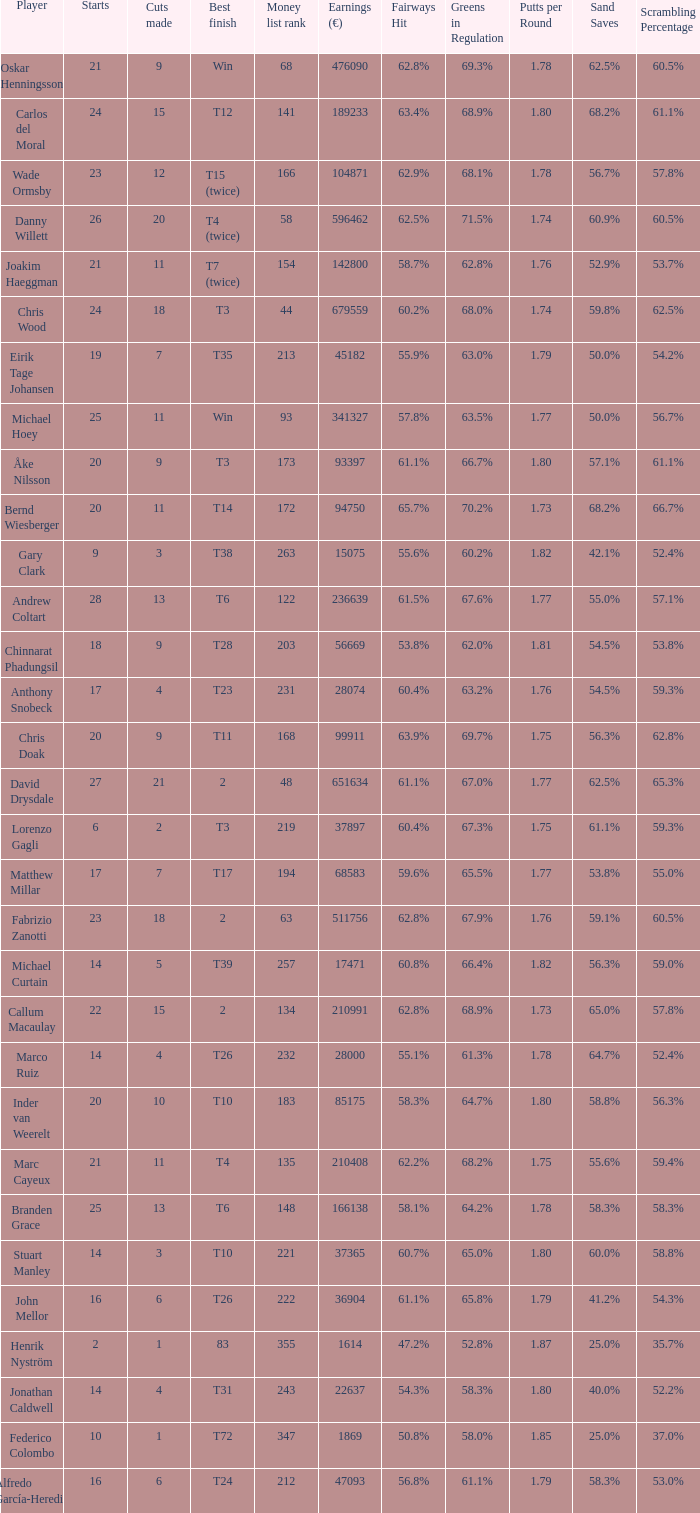How many earnings values are associated with players who had a best finish of T38? 1.0. I'm looking to parse the entire table for insights. Could you assist me with that? {'header': ['Player', 'Starts', 'Cuts made', 'Best finish', 'Money list rank', 'Earnings (€)', 'Fairways Hit', 'Greens in Regulation', 'Putts per Round', 'Sand Saves', 'Scrambling Percentage'], 'rows': [['Oskar Henningsson', '21', '9', 'Win', '68', '476090', '62.8%', '69.3%', '1.78', '62.5%', '60.5%'], ['Carlos del Moral', '24', '15', 'T12', '141', '189233', '63.4%', '68.9%', '1.80', '68.2%', '61.1%'], ['Wade Ormsby', '23', '12', 'T15 (twice)', '166', '104871', '62.9%', '68.1%', '1.78', '56.7%', '57.8%'], ['Danny Willett', '26', '20', 'T4 (twice)', '58', '596462', '62.5%', '71.5%', '1.74', '60.9%', '60.5%'], ['Joakim Haeggman', '21', '11', 'T7 (twice)', '154', '142800', '58.7%', '62.8%', '1.76', '52.9%', '53.7%'], ['Chris Wood', '24', '18', 'T3', '44', '679559', '60.2%', '68.0%', '1.74', '59.8%', '62.5%'], ['Eirik Tage Johansen', '19', '7', 'T35', '213', '45182', '55.9%', '63.0%', '1.79', '50.0%', '54.2%'], ['Michael Hoey', '25', '11', 'Win', '93', '341327', '57.8%', '63.5%', '1.77', '50.0%', '56.7%'], ['Åke Nilsson', '20', '9', 'T3', '173', '93397', '61.1%', '66.7%', '1.80', '57.1%', '61.1%'], ['Bernd Wiesberger', '20', '11', 'T14', '172', '94750', '65.7%', '70.2%', '1.73', '68.2%', '66.7%'], ['Gary Clark', '9', '3', 'T38', '263', '15075', '55.6%', '60.2%', '1.82', '42.1%', '52.4%'], ['Andrew Coltart', '28', '13', 'T6', '122', '236639', '61.5%', '67.6%', '1.77', '55.0%', '57.1%'], ['Chinnarat Phadungsil', '18', '9', 'T28', '203', '56669', '53.8%', '62.0%', '1.81', '54.5%', '53.8%'], ['Anthony Snobeck', '17', '4', 'T23', '231', '28074', '60.4%', '63.2%', '1.76', '54.5%', '59.3%'], ['Chris Doak', '20', '9', 'T11', '168', '99911', '63.9%', '69.7%', '1.75', '56.3%', '62.8%'], ['David Drysdale', '27', '21', '2', '48', '651634', '61.1%', '67.0%', '1.77', '62.5%', '65.3%'], ['Lorenzo Gagli', '6', '2', 'T3', '219', '37897', '60.4%', '67.3%', '1.75', '61.1%', '59.3%'], ['Matthew Millar', '17', '7', 'T17', '194', '68583', '59.6%', '65.5%', '1.77', '53.8%', '55.0%'], ['Fabrizio Zanotti', '23', '18', '2', '63', '511756', '62.8%', '67.9%', '1.76', '59.1%', '60.5%'], ['Michael Curtain', '14', '5', 'T39', '257', '17471', '60.8%', '66.4%', '1.82', '56.3%', '59.0%'], ['Callum Macaulay', '22', '15', '2', '134', '210991', '62.8%', '68.9%', '1.73', '65.0%', '57.8%'], ['Marco Ruiz', '14', '4', 'T26', '232', '28000', '55.1%', '61.3%', '1.78', '64.7%', '52.4%'], ['Inder van Weerelt', '20', '10', 'T10', '183', '85175', '58.3%', '64.7%', '1.80', '58.8%', '56.3%'], ['Marc Cayeux', '21', '11', 'T4', '135', '210408', '62.2%', '68.2%', '1.75', '55.6%', '59.4%'], ['Branden Grace', '25', '13', 'T6', '148', '166138', '58.1%', '64.2%', '1.78', '58.3%', '58.3%'], ['Stuart Manley', '14', '3', 'T10', '221', '37365', '60.7%', '65.0%', '1.80', '60.0%', '58.8%'], ['John Mellor', '16', '6', 'T26', '222', '36904', '61.1%', '65.8%', '1.79', '41.2%', '54.3%'], ['Henrik Nyström', '2', '1', '83', '355', '1614', '47.2%', '52.8%', '1.87', '25.0%', '35.7%'], ['Jonathan Caldwell', '14', '4', 'T31', '243', '22637', '54.3%', '58.3%', '1.80', '40.0%', '52.2%'], ['Federico Colombo', '10', '1', 'T72', '347', '1869', '50.8%', '58.0%', '1.85', '25.0%', '37.0%'], ['Alfredo García-Heredia', '16', '6', 'T24', '212', '47093', '56.8%', '61.1%', '1.79', '58.3%', '53.0%']]} 